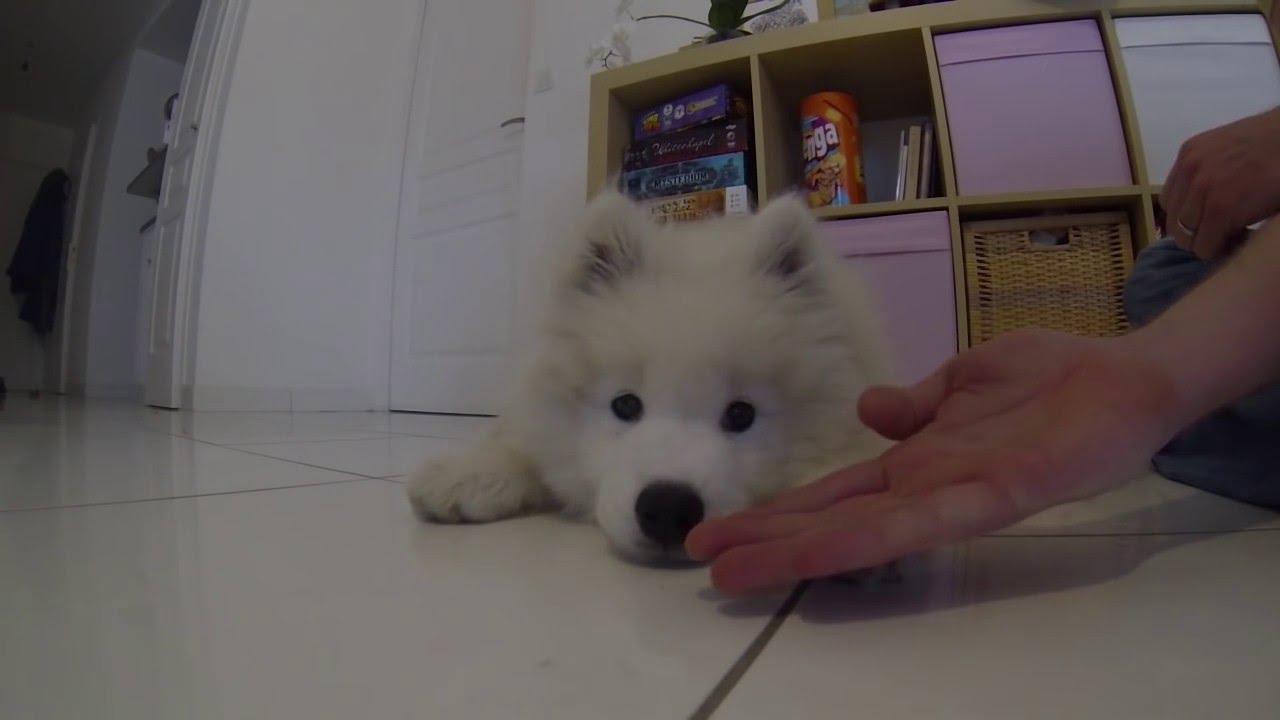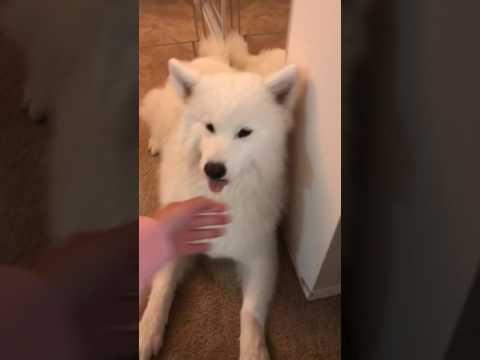The first image is the image on the left, the second image is the image on the right. For the images shown, is this caption "there is at least one dog stading in the snow in the image pair" true? Answer yes or no. No. The first image is the image on the left, the second image is the image on the right. Assess this claim about the two images: "At least one dog is in the snow.". Correct or not? Answer yes or no. No. 